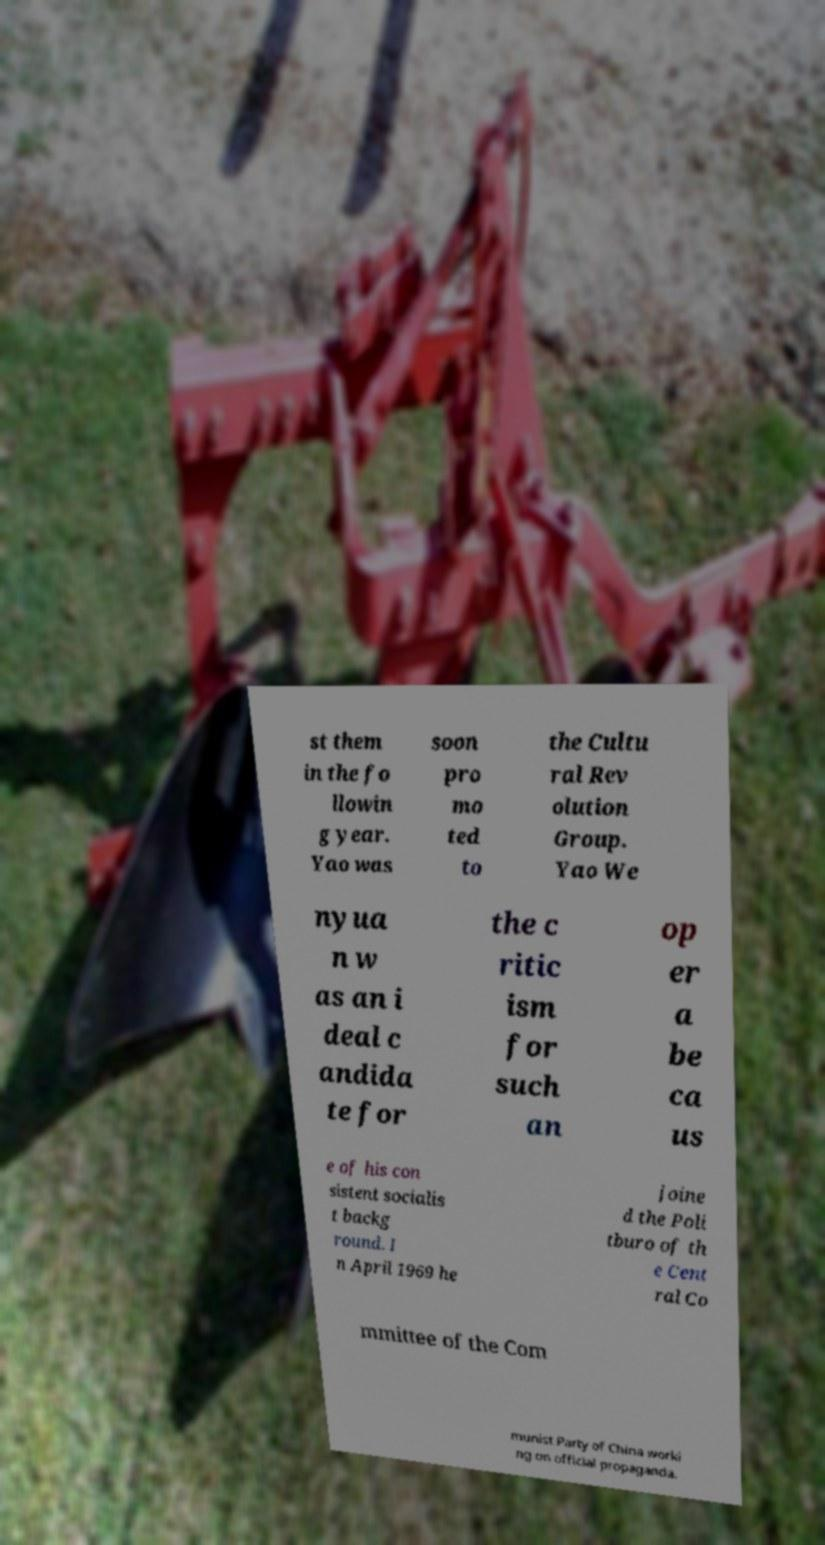Could you assist in decoding the text presented in this image and type it out clearly? st them in the fo llowin g year. Yao was soon pro mo ted to the Cultu ral Rev olution Group. Yao We nyua n w as an i deal c andida te for the c ritic ism for such an op er a be ca us e of his con sistent socialis t backg round. I n April 1969 he joine d the Poli tburo of th e Cent ral Co mmittee of the Com munist Party of China worki ng on official propaganda. 